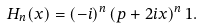Convert formula to latex. <formula><loc_0><loc_0><loc_500><loc_500>H _ { n } ( x ) = ( - i ) ^ { n } \left ( p + 2 i x \right ) ^ { n } 1 .</formula> 